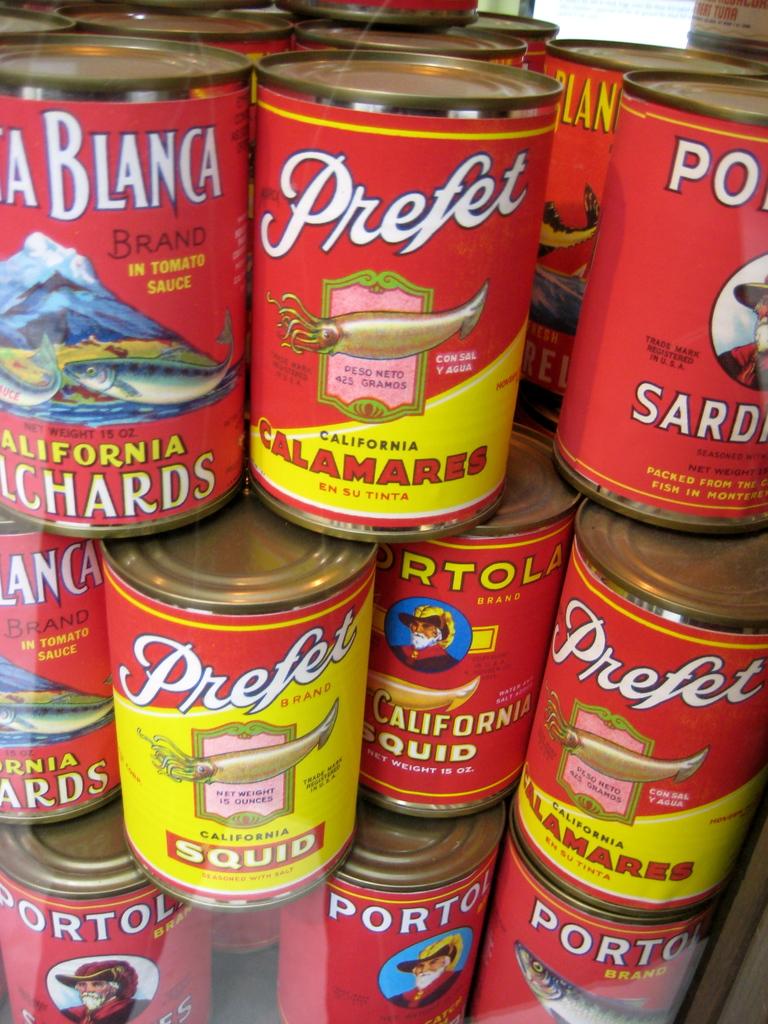What kind of food are inside these cans?
Keep it short and to the point. Seafood. Whats in the can?
Your response must be concise. Calamares. 